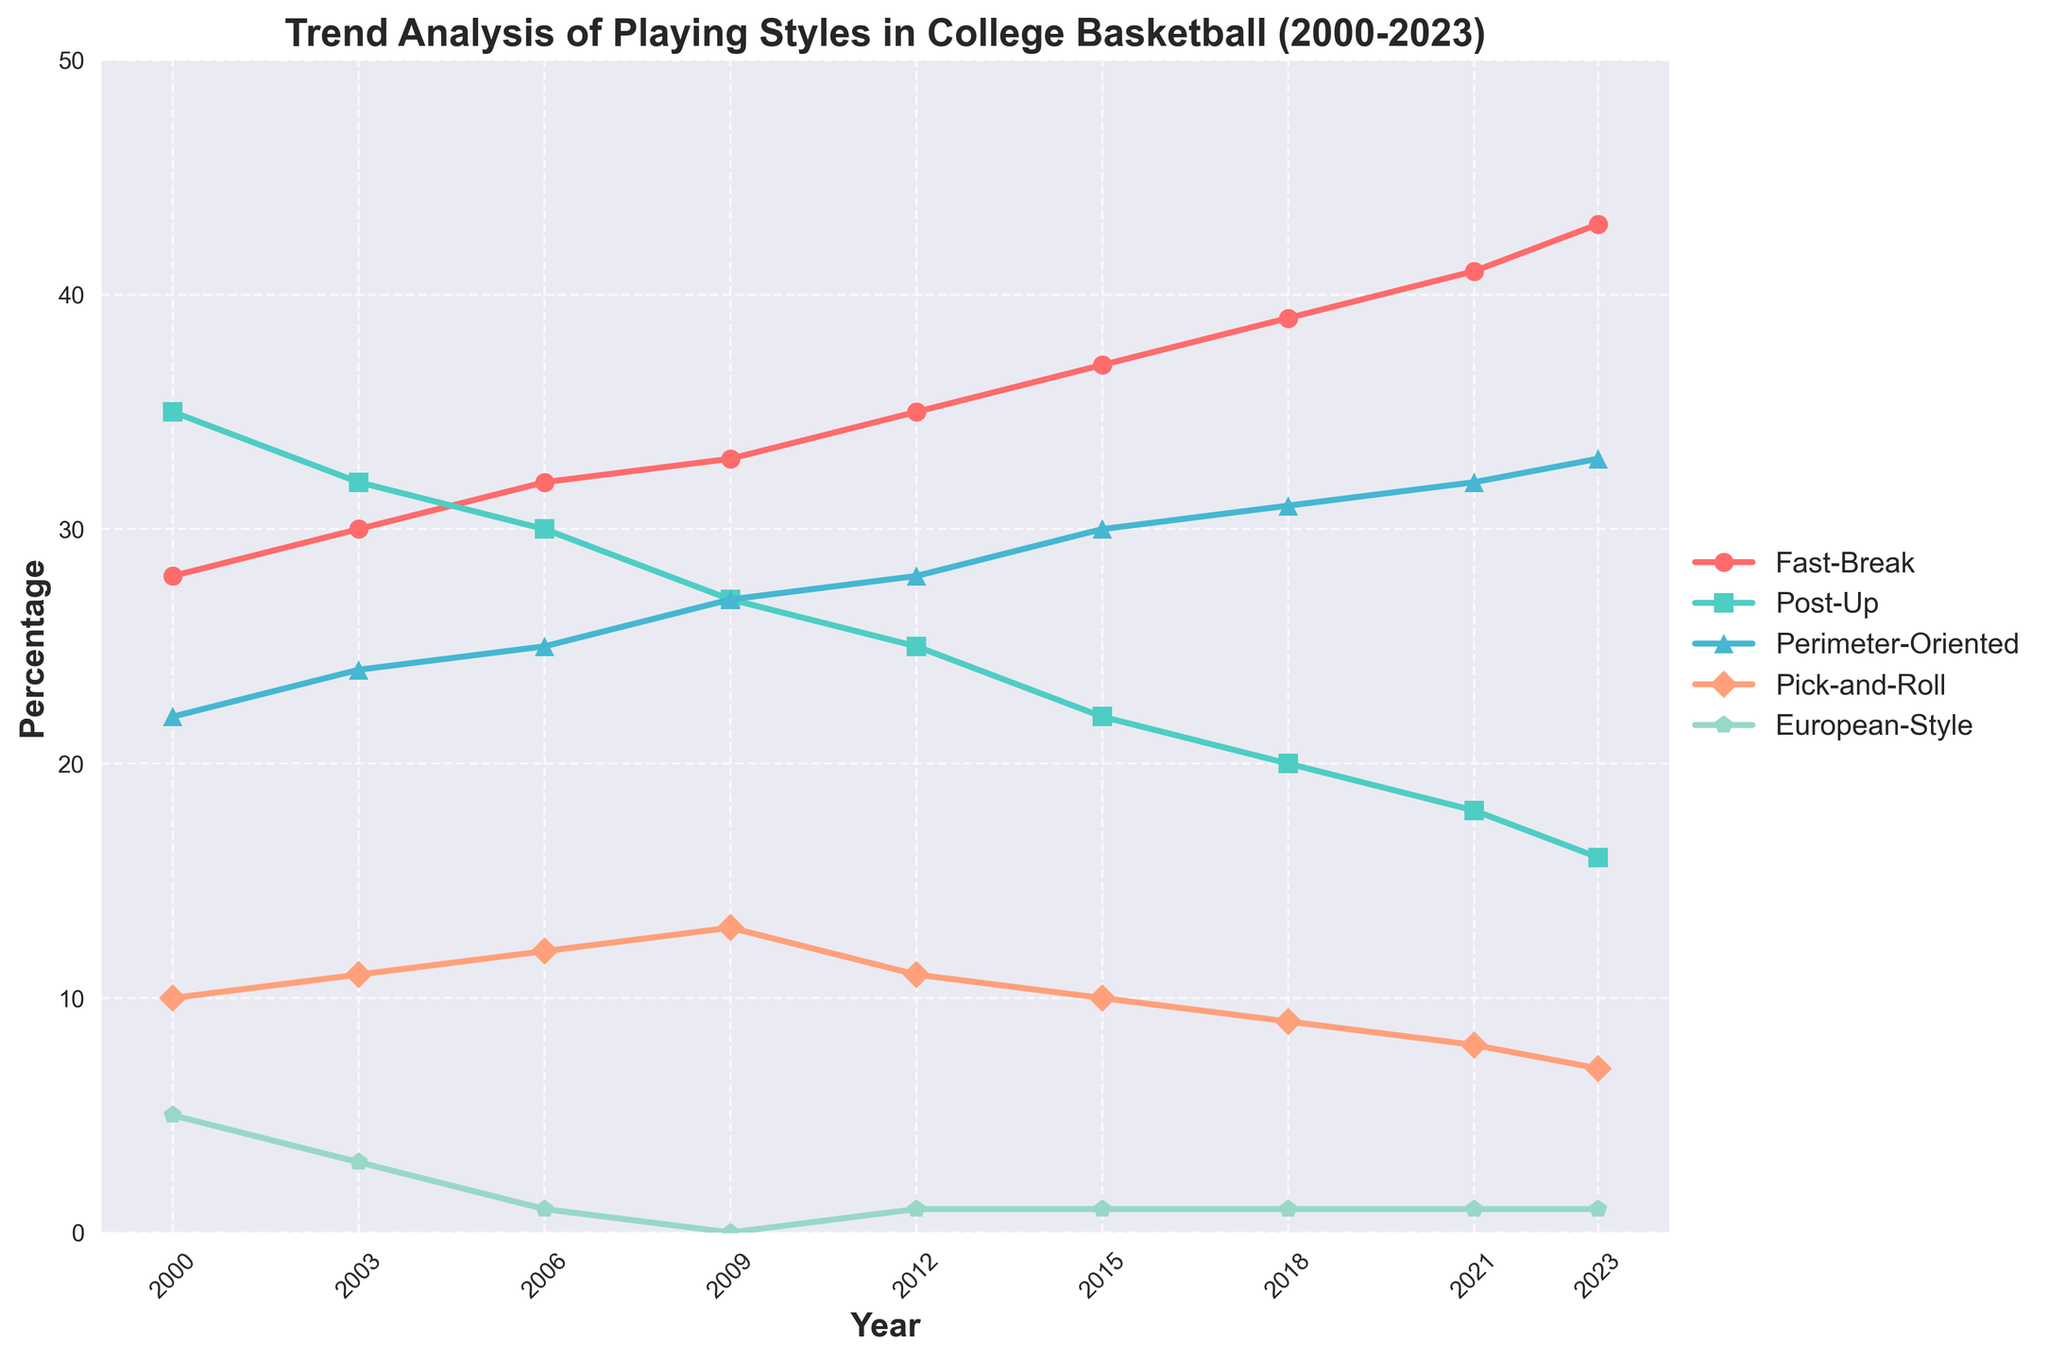What playing style had the highest percentage in 2009? From the chart, the highest percentage in 2009 is given by the red line, representing the Fast-Break style.
Answer: Fast-Break Which playing style showed a consistent increase over the years from 2000 to 2023? By visually tracking the lines, the Fast-Break style shows a consistent increase in percentage every year from 2000 to 2023.
Answer: Fast-Break In which year did the European-Style playing style reach its lowest percentage, and what was that percentage? The lowest point for the European-Style is in 2009, where it reaches 0%.
Answer: 2009, 0% Compare the percentages of the Post-Up and Perimeter-Oriented styles in 2015. Which one was higher, and by what difference? The Post-Up style was at 22%, and the Perimeter-Oriented style was at 30% in 2015. The difference is 30% - 22% = 8%.
Answer: Perimeter-Oriented, 8% What is the sum of percentages for all playing styles in the year 2021? Summing the percentages for 2021: Fast-Break 41% + Post-Up 18% + Perimeter-Oriented 32% + Pick-and-Roll 8% + European-Style 1% = 100%.
Answer: 100% Which playing style decreased the most between 2000 and 2023, and by how much? The Post-Up style decreased from 35% in 2000 to 16% in 2023, which is a decrease of 35% - 16% = 19%.
Answer: Post-Up, 19% In 2023, were there any playing styles with the same percentage value? If so, identify them. In 2023, only the European-Style has a unique percentage of 1%. No other styles share the same percentage.
Answer: No What is the average percentage of the Pick-and-Roll style across all years? The percentages for Pick-and-Roll from 2000 to 2023 are 10, 11, 12, 13, 11, 10, 9, 8, 7. The sum is 91, and the count is 9. Therefore, the average is 91/9 = 10.11%.
Answer: 10.11% Which year saw the highest cumulative percentage for the Fast-Break and Perimeter-Oriented styles combined? Adding up the percentages for Fast-Break and Perimeter-Oriented for each year, 2023 has the highest combined value of 43% + 33% = 76%.
Answer: 2023 